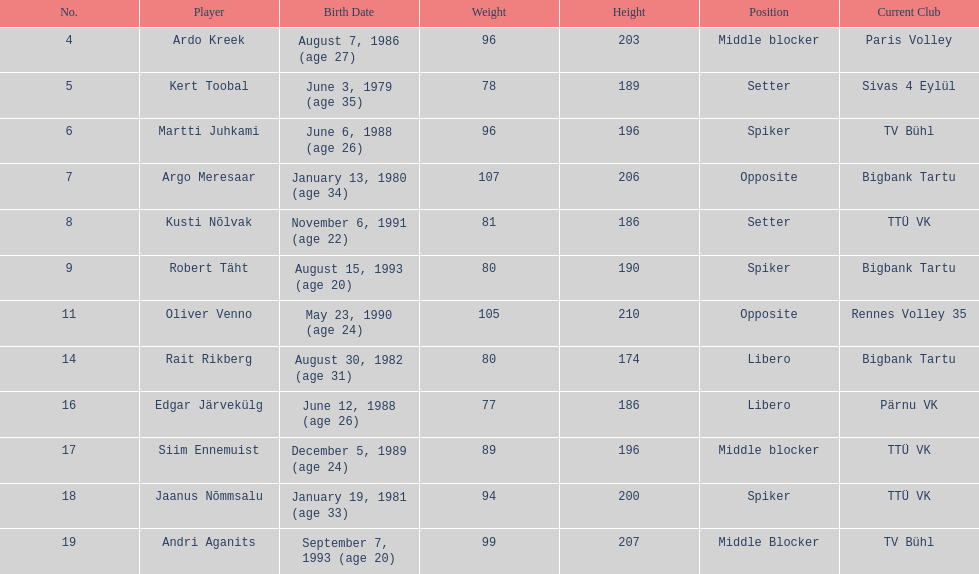What is the height difference between oliver venno and rait rikberg? 36. 